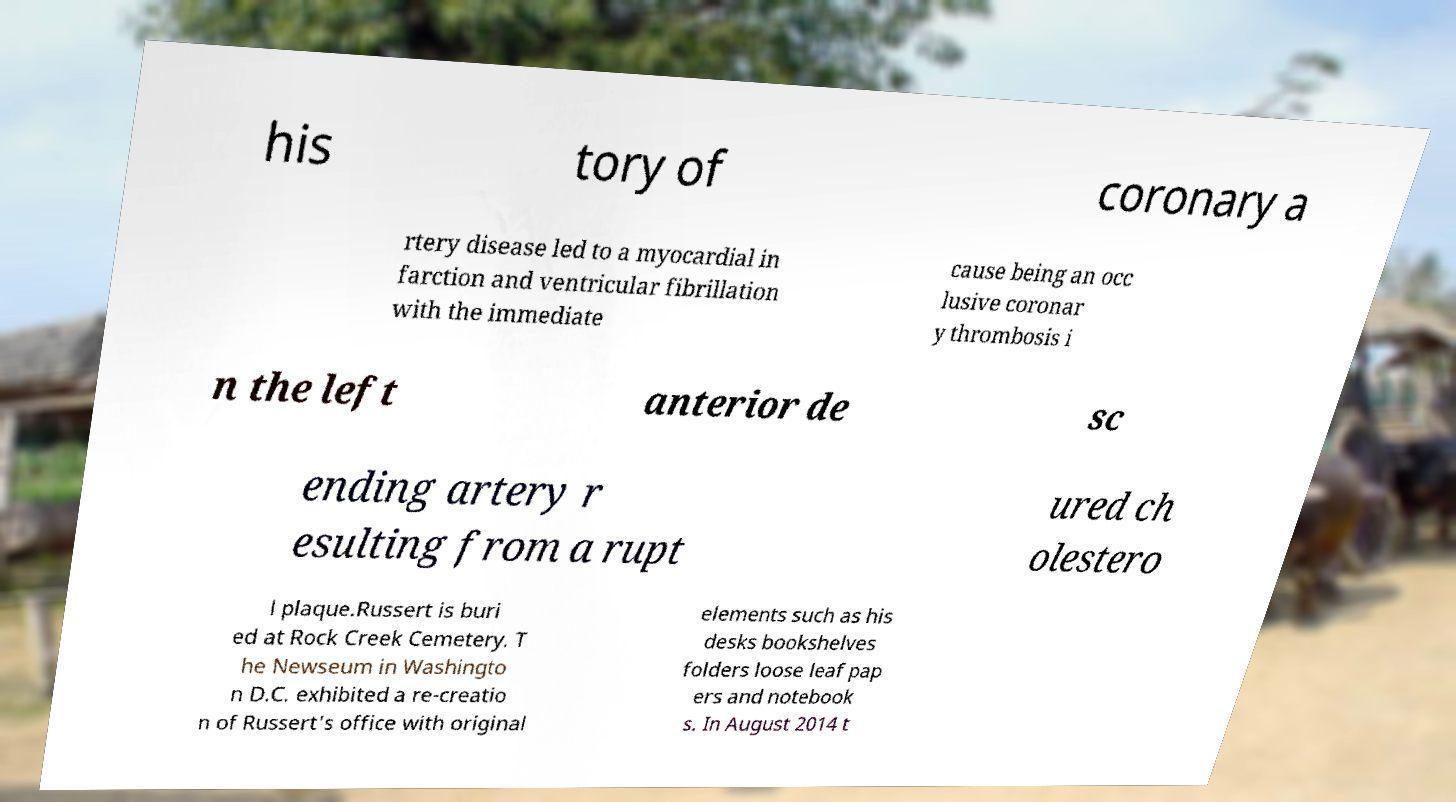Please read and relay the text visible in this image. What does it say? his tory of coronary a rtery disease led to a myocardial in farction and ventricular fibrillation with the immediate cause being an occ lusive coronar y thrombosis i n the left anterior de sc ending artery r esulting from a rupt ured ch olestero l plaque.Russert is buri ed at Rock Creek Cemetery. T he Newseum in Washingto n D.C. exhibited a re-creatio n of Russert's office with original elements such as his desks bookshelves folders loose leaf pap ers and notebook s. In August 2014 t 